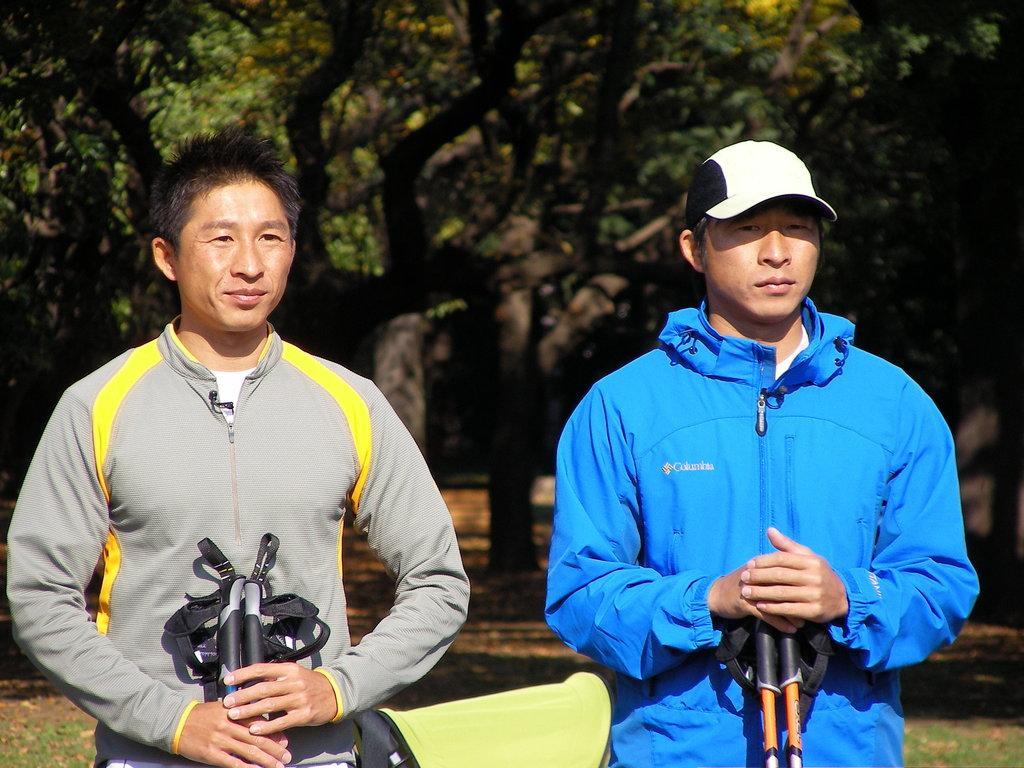Describe this image in one or two sentences. In this image we can see men standing on the ground. In the background there are trees and shredded leaves on the ground. 